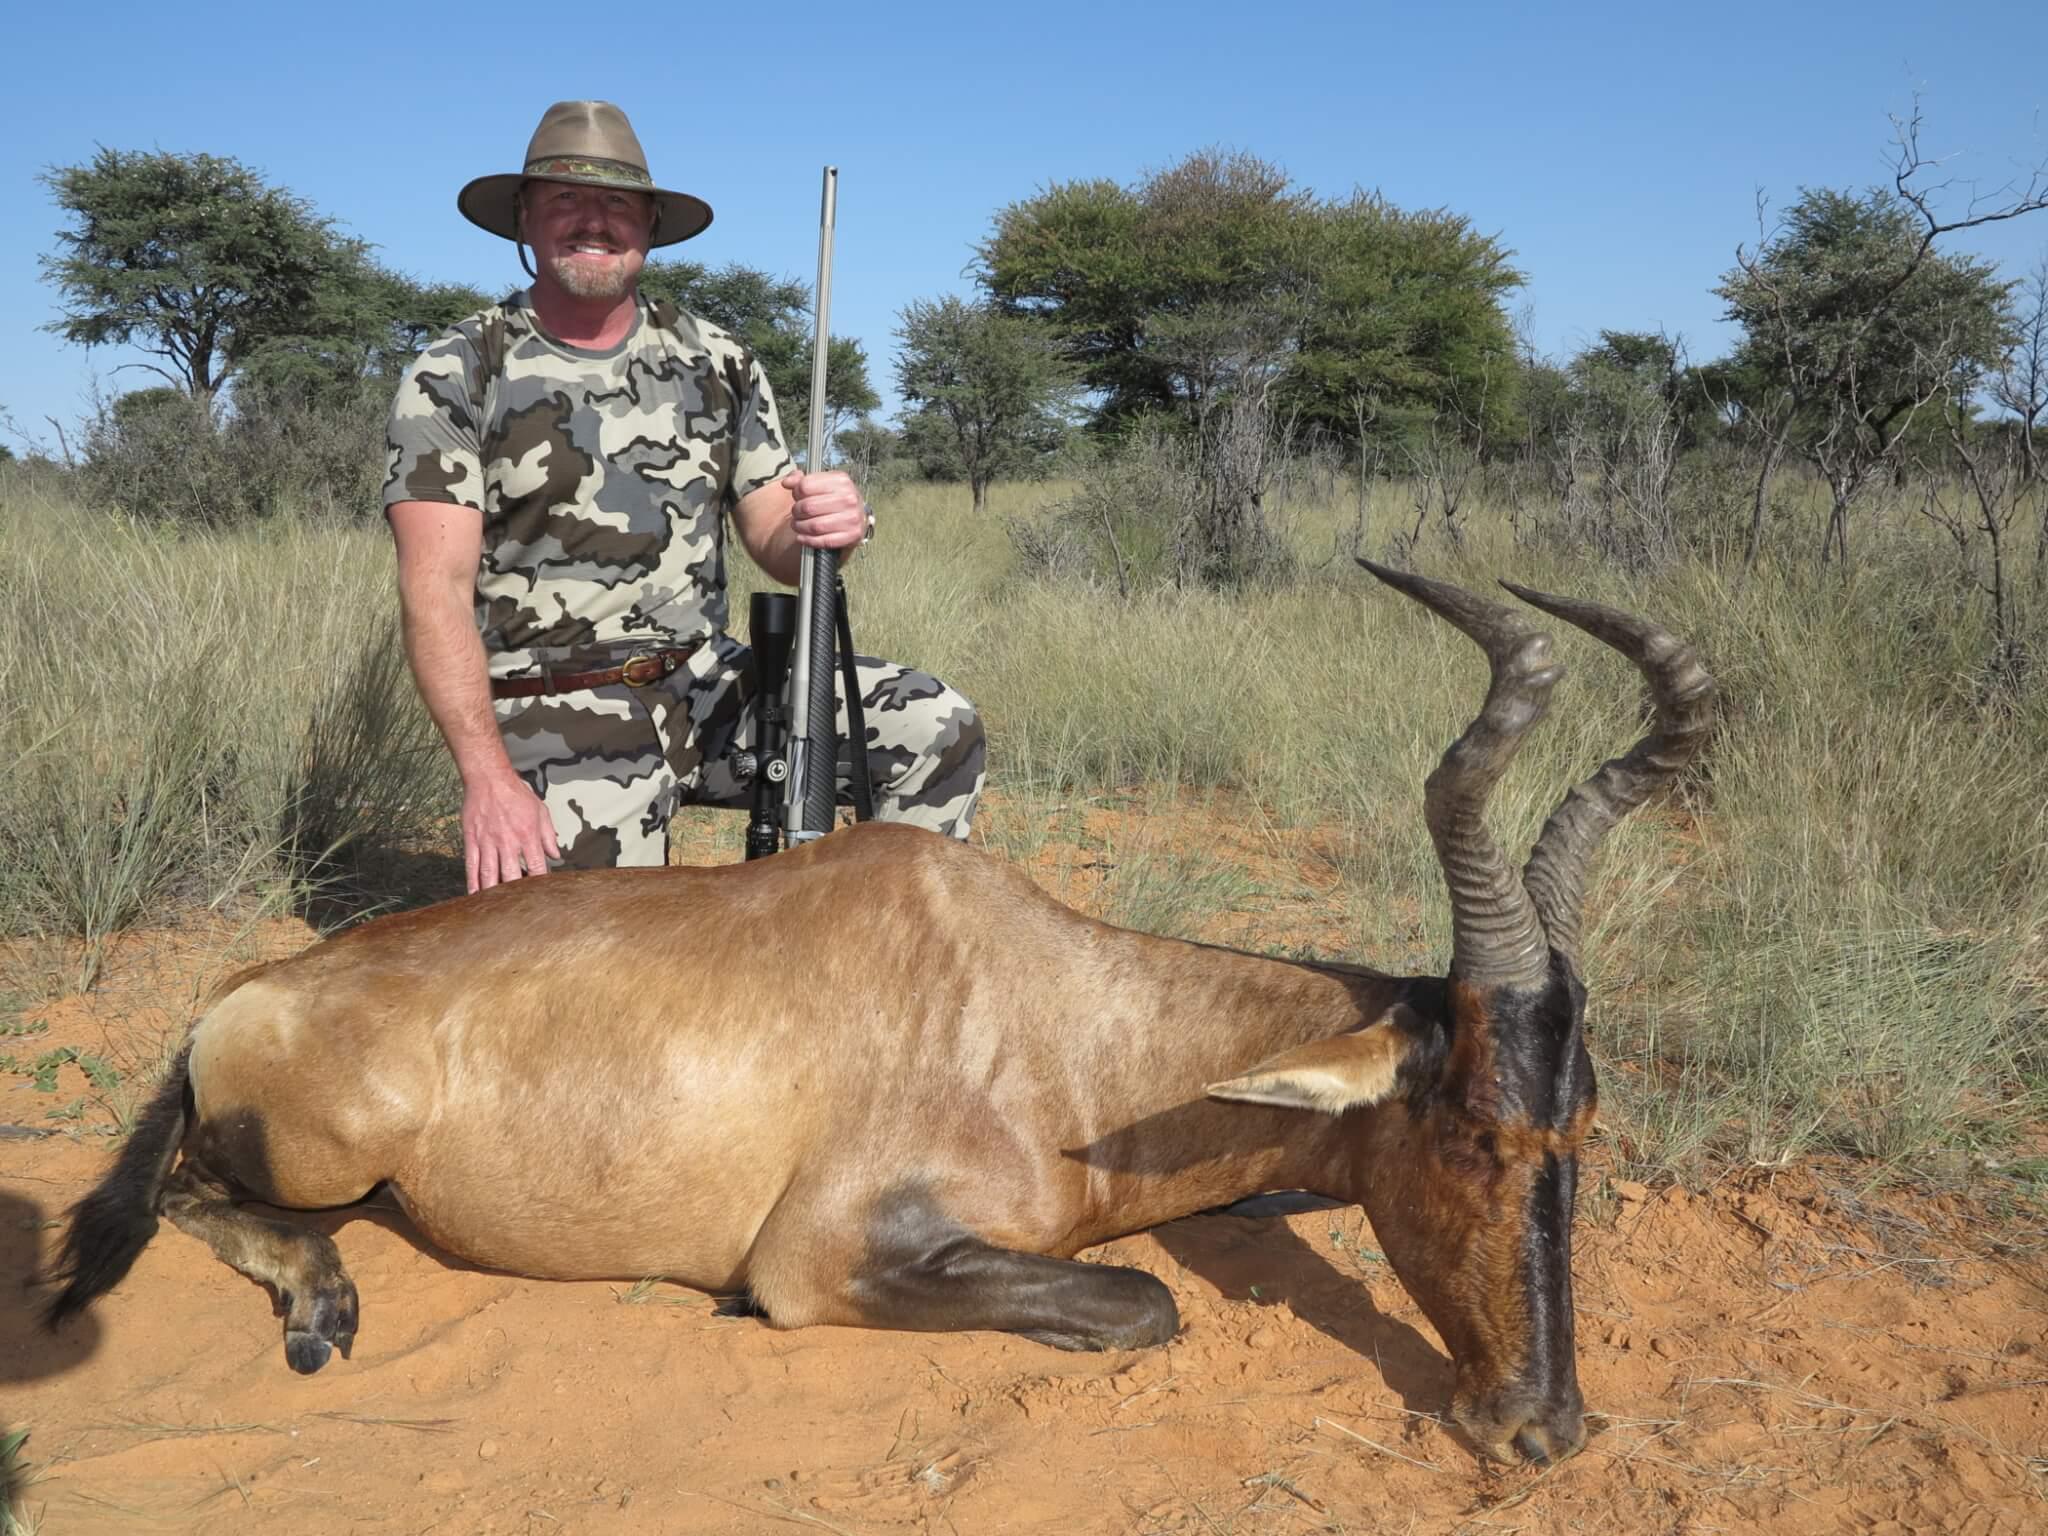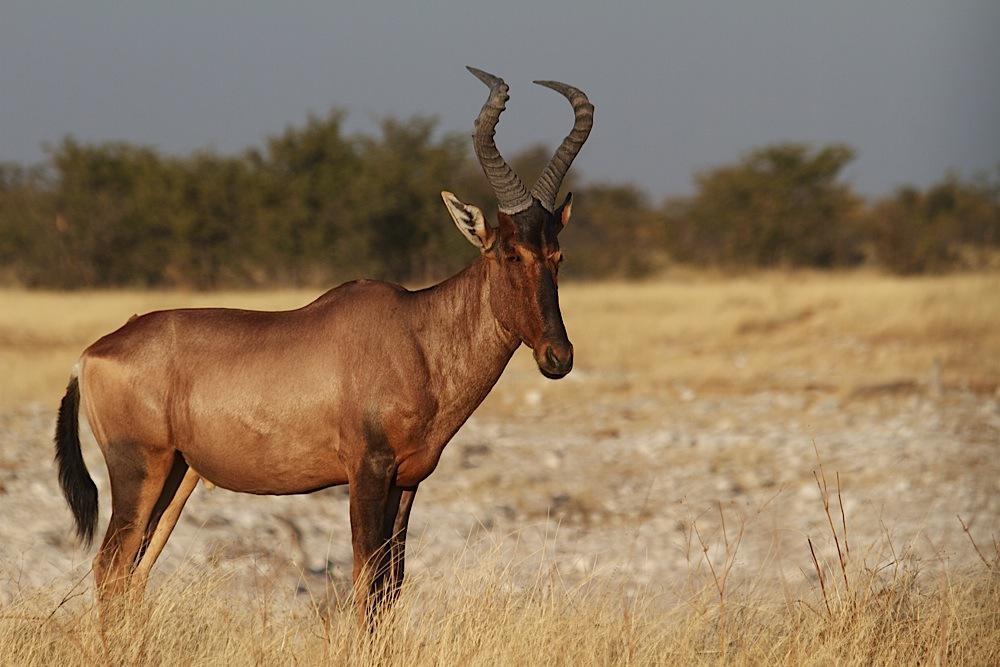The first image is the image on the left, the second image is the image on the right. Analyze the images presented: Is the assertion "An image shows a rightward-facing adult horned animal and young hornless animal, one ahead of the other but not overlapping." valid? Answer yes or no. No. The first image is the image on the left, the second image is the image on the right. For the images displayed, is the sentence "The left and right image contains a total of the elks." factually correct? Answer yes or no. No. 